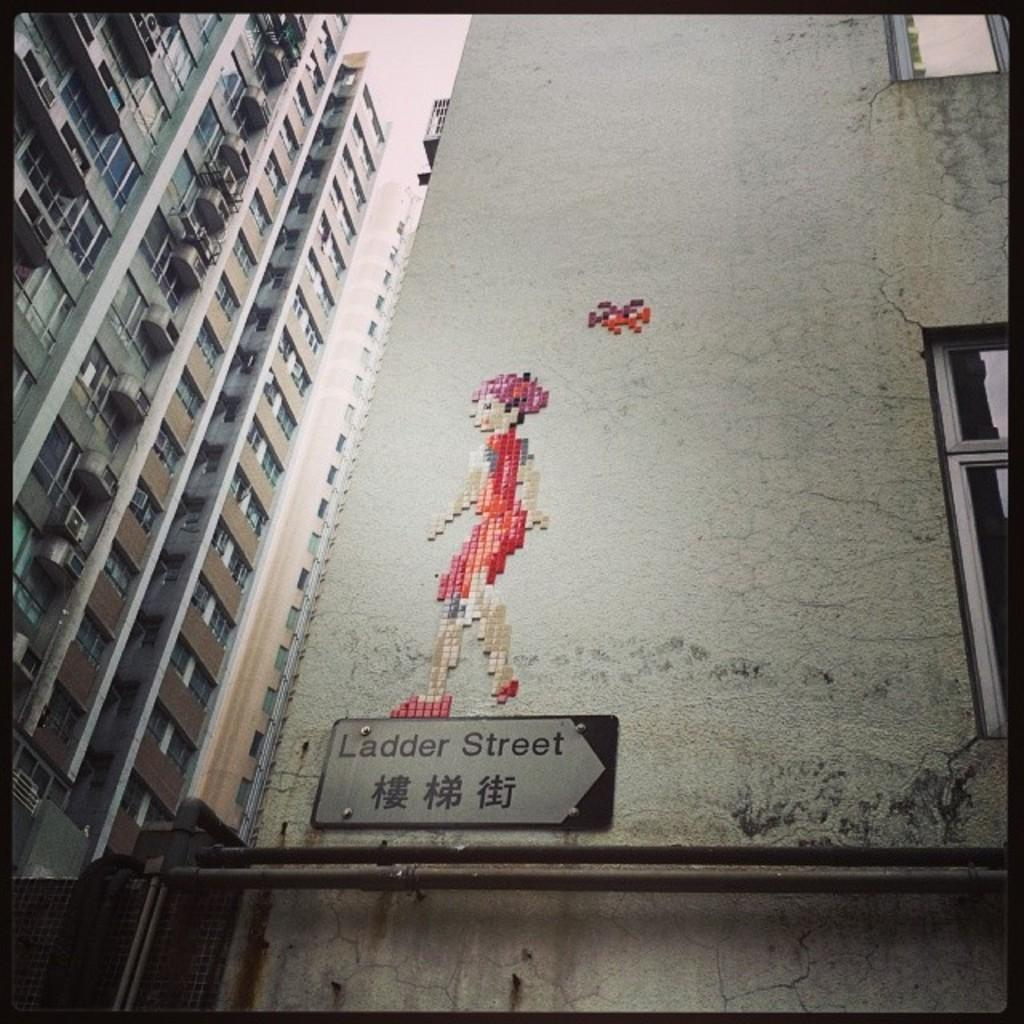What type of structures can be seen in the image? There are buildings in the image. What else is present in the image besides the buildings? There are pipes and a board visible in the image. Can you describe the picture associated with a building in the image? Yes, there is a picture associated with a building in the image. What is visible in the background of the image? The sky is visible in the background of the image. How many pancakes are stacked on the board in the image? There are no pancakes present in the image; it features buildings, pipes, and a board with a picture. 